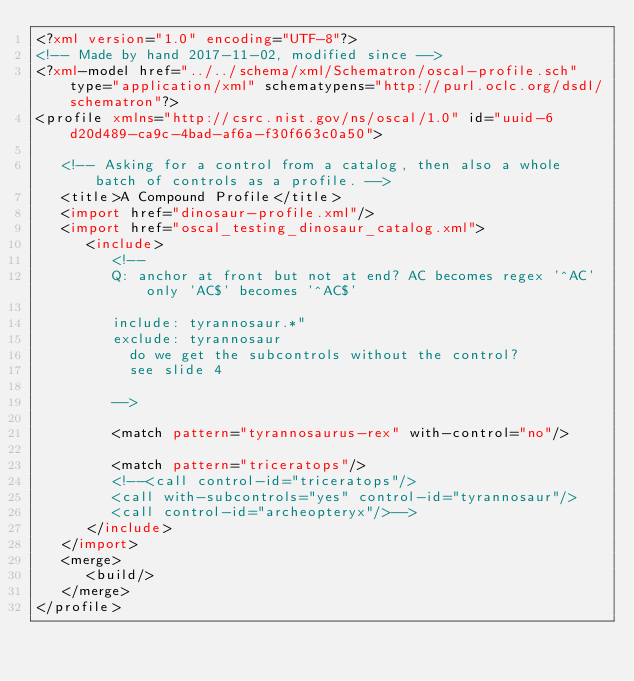Convert code to text. <code><loc_0><loc_0><loc_500><loc_500><_XML_><?xml version="1.0" encoding="UTF-8"?>
<!-- Made by hand 2017-11-02, modified since -->
<?xml-model href="../../schema/xml/Schematron/oscal-profile.sch" type="application/xml" schematypens="http://purl.oclc.org/dsdl/schematron"?>
<profile xmlns="http://csrc.nist.gov/ns/oscal/1.0" id="uuid-6d20d489-ca9c-4bad-af6a-f30f663c0a50">

   <!-- Asking for a control from a catalog, then also a whole batch of controls as a profile. -->
   <title>A Compound Profile</title>
   <import href="dinosaur-profile.xml"/>
   <import href="oscal_testing_dinosaur_catalog.xml">
      <include>
         <!--
         Q: anchor at front but not at end? AC becomes regex '^AC' only 'AC$' becomes '^AC$'
         
         include: tyrannosaur.*"
         exclude: tyrannosaur
           do we get the subcontrols without the control?
           see slide 4
         
         -->
         
         <match pattern="tyrannosaurus-rex" with-control="no"/>
         
         <match pattern="triceratops"/>
         <!--<call control-id="triceratops"/>
         <call with-subcontrols="yes" control-id="tyrannosaur"/>
         <call control-id="archeopteryx"/>-->
      </include>
   </import>
   <merge>
      <build/>
   </merge>
</profile>
</code> 